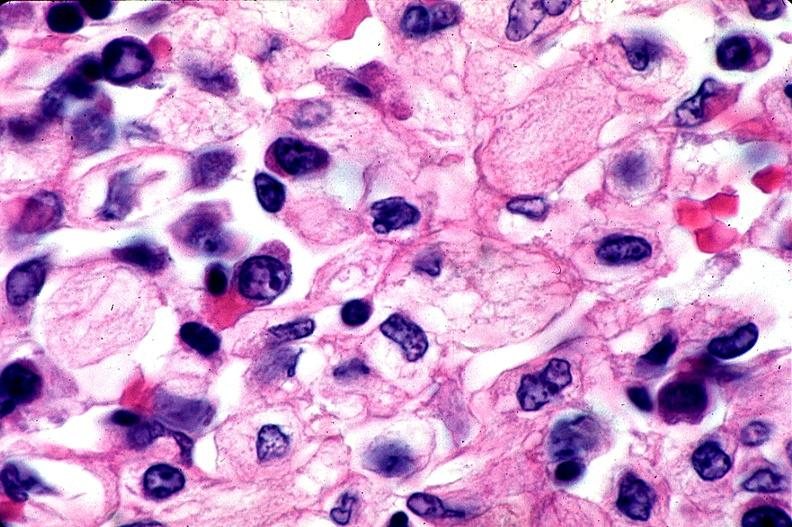what does this image show?
Answer the question using a single word or phrase. Gaucher disease 